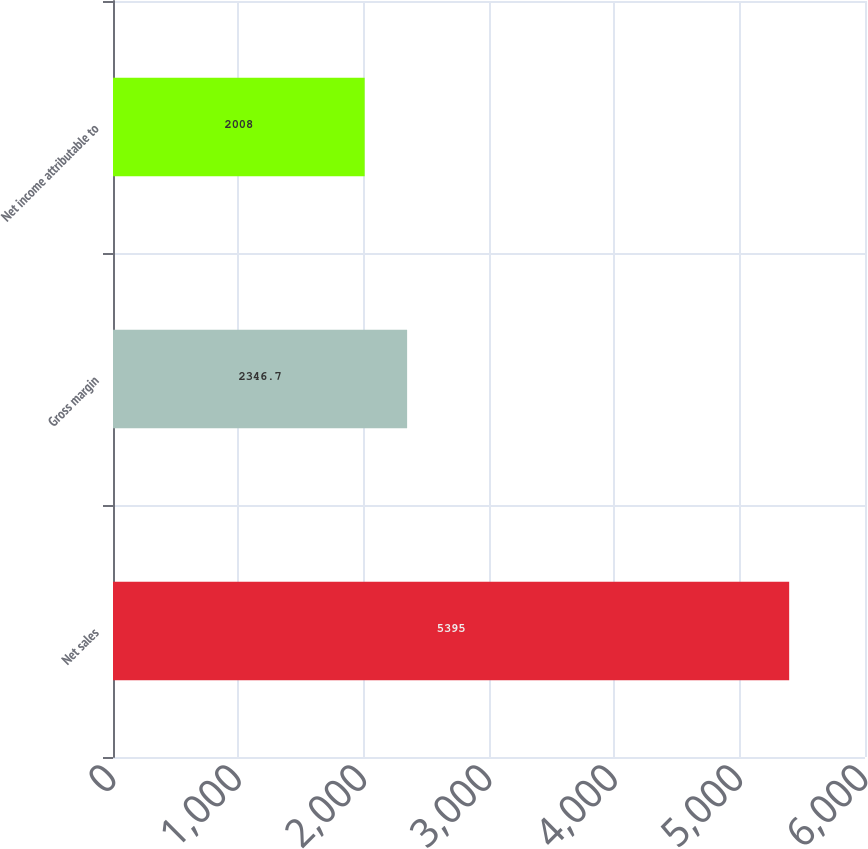Convert chart to OTSL. <chart><loc_0><loc_0><loc_500><loc_500><bar_chart><fcel>Net sales<fcel>Gross margin<fcel>Net income attributable to<nl><fcel>5395<fcel>2346.7<fcel>2008<nl></chart> 